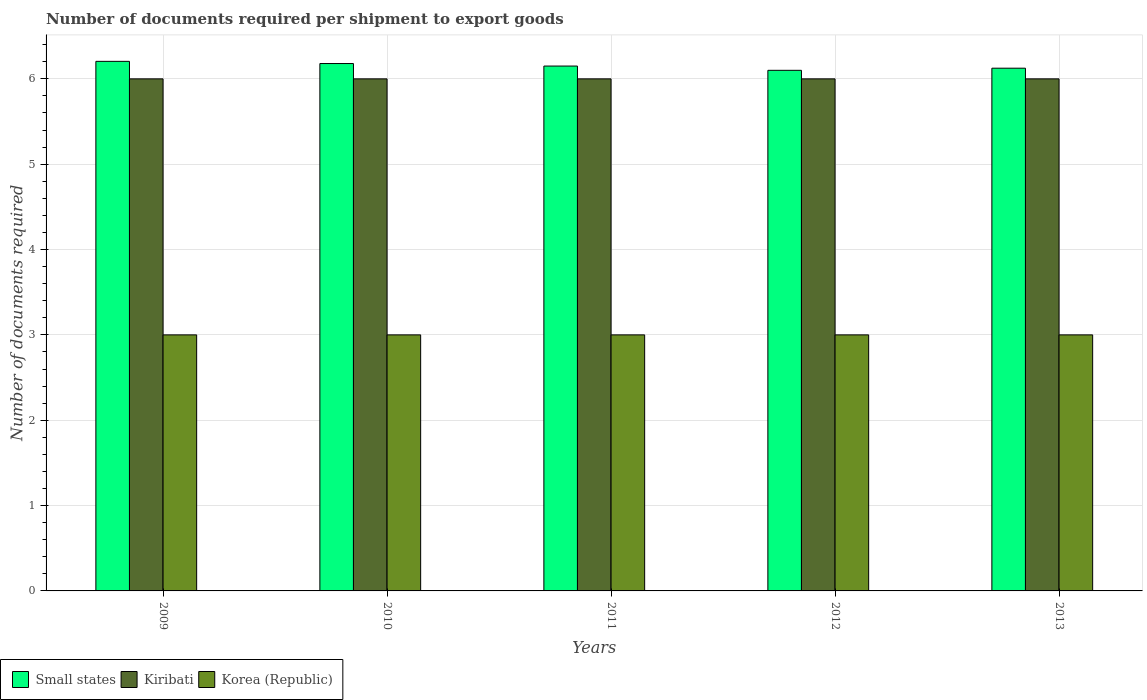How many groups of bars are there?
Your response must be concise. 5. Are the number of bars per tick equal to the number of legend labels?
Your answer should be compact. Yes. Are the number of bars on each tick of the X-axis equal?
Give a very brief answer. Yes. How many bars are there on the 1st tick from the left?
Ensure brevity in your answer.  3. How many bars are there on the 2nd tick from the right?
Offer a very short reply. 3. What is the label of the 1st group of bars from the left?
Provide a succinct answer. 2009. What is the number of documents required per shipment to export goods in Kiribati in 2010?
Your answer should be compact. 6. Across all years, what is the maximum number of documents required per shipment to export goods in Korea (Republic)?
Provide a short and direct response. 3. In which year was the number of documents required per shipment to export goods in Kiribati maximum?
Your answer should be very brief. 2009. In which year was the number of documents required per shipment to export goods in Kiribati minimum?
Keep it short and to the point. 2009. What is the total number of documents required per shipment to export goods in Kiribati in the graph?
Keep it short and to the point. 30. What is the difference between the number of documents required per shipment to export goods in Small states in 2009 and that in 2012?
Your answer should be compact. 0.11. What is the difference between the number of documents required per shipment to export goods in Kiribati in 2009 and the number of documents required per shipment to export goods in Korea (Republic) in 2012?
Keep it short and to the point. 3. In the year 2012, what is the difference between the number of documents required per shipment to export goods in Small states and number of documents required per shipment to export goods in Kiribati?
Give a very brief answer. 0.1. In how many years, is the number of documents required per shipment to export goods in Kiribati greater than 5.2?
Your answer should be very brief. 5. What is the ratio of the number of documents required per shipment to export goods in Kiribati in 2009 to that in 2013?
Provide a succinct answer. 1. Is the number of documents required per shipment to export goods in Kiribati in 2009 less than that in 2010?
Offer a terse response. No. Is the difference between the number of documents required per shipment to export goods in Small states in 2010 and 2013 greater than the difference between the number of documents required per shipment to export goods in Kiribati in 2010 and 2013?
Give a very brief answer. Yes. In how many years, is the number of documents required per shipment to export goods in Small states greater than the average number of documents required per shipment to export goods in Small states taken over all years?
Give a very brief answer. 2. Is the sum of the number of documents required per shipment to export goods in Kiribati in 2010 and 2011 greater than the maximum number of documents required per shipment to export goods in Small states across all years?
Your response must be concise. Yes. What does the 3rd bar from the right in 2009 represents?
Provide a short and direct response. Small states. Is it the case that in every year, the sum of the number of documents required per shipment to export goods in Kiribati and number of documents required per shipment to export goods in Small states is greater than the number of documents required per shipment to export goods in Korea (Republic)?
Your answer should be compact. Yes. How many bars are there?
Keep it short and to the point. 15. How many years are there in the graph?
Make the answer very short. 5. What is the difference between two consecutive major ticks on the Y-axis?
Your answer should be compact. 1. Are the values on the major ticks of Y-axis written in scientific E-notation?
Your response must be concise. No. Does the graph contain any zero values?
Give a very brief answer. No. Does the graph contain grids?
Your response must be concise. Yes. How many legend labels are there?
Your answer should be very brief. 3. How are the legend labels stacked?
Your answer should be compact. Horizontal. What is the title of the graph?
Keep it short and to the point. Number of documents required per shipment to export goods. Does "Cote d'Ivoire" appear as one of the legend labels in the graph?
Make the answer very short. No. What is the label or title of the Y-axis?
Provide a succinct answer. Number of documents required. What is the Number of documents required of Small states in 2009?
Give a very brief answer. 6.21. What is the Number of documents required of Kiribati in 2009?
Provide a short and direct response. 6. What is the Number of documents required in Small states in 2010?
Your answer should be compact. 6.18. What is the Number of documents required in Kiribati in 2010?
Your response must be concise. 6. What is the Number of documents required of Small states in 2011?
Your response must be concise. 6.15. What is the Number of documents required in Small states in 2012?
Make the answer very short. 6.1. What is the Number of documents required of Kiribati in 2012?
Keep it short and to the point. 6. What is the Number of documents required of Small states in 2013?
Keep it short and to the point. 6.12. What is the Number of documents required of Korea (Republic) in 2013?
Give a very brief answer. 3. Across all years, what is the maximum Number of documents required of Small states?
Your response must be concise. 6.21. Across all years, what is the maximum Number of documents required in Kiribati?
Offer a very short reply. 6. Across all years, what is the minimum Number of documents required in Small states?
Your answer should be compact. 6.1. What is the total Number of documents required of Small states in the graph?
Your response must be concise. 30.76. What is the total Number of documents required of Kiribati in the graph?
Provide a succinct answer. 30. What is the difference between the Number of documents required in Small states in 2009 and that in 2010?
Make the answer very short. 0.03. What is the difference between the Number of documents required in Small states in 2009 and that in 2011?
Your response must be concise. 0.06. What is the difference between the Number of documents required in Kiribati in 2009 and that in 2011?
Ensure brevity in your answer.  0. What is the difference between the Number of documents required of Small states in 2009 and that in 2012?
Ensure brevity in your answer.  0.11. What is the difference between the Number of documents required in Kiribati in 2009 and that in 2012?
Provide a short and direct response. 0. What is the difference between the Number of documents required in Small states in 2009 and that in 2013?
Your answer should be very brief. 0.08. What is the difference between the Number of documents required of Kiribati in 2009 and that in 2013?
Your answer should be compact. 0. What is the difference between the Number of documents required in Korea (Republic) in 2009 and that in 2013?
Keep it short and to the point. 0. What is the difference between the Number of documents required in Small states in 2010 and that in 2011?
Your answer should be very brief. 0.03. What is the difference between the Number of documents required of Kiribati in 2010 and that in 2011?
Provide a succinct answer. 0. What is the difference between the Number of documents required of Small states in 2010 and that in 2012?
Ensure brevity in your answer.  0.08. What is the difference between the Number of documents required of Korea (Republic) in 2010 and that in 2012?
Ensure brevity in your answer.  0. What is the difference between the Number of documents required of Small states in 2010 and that in 2013?
Keep it short and to the point. 0.05. What is the difference between the Number of documents required in Kiribati in 2011 and that in 2012?
Offer a terse response. 0. What is the difference between the Number of documents required of Small states in 2011 and that in 2013?
Offer a terse response. 0.03. What is the difference between the Number of documents required of Korea (Republic) in 2011 and that in 2013?
Your answer should be very brief. 0. What is the difference between the Number of documents required of Small states in 2012 and that in 2013?
Ensure brevity in your answer.  -0.03. What is the difference between the Number of documents required of Kiribati in 2012 and that in 2013?
Provide a short and direct response. 0. What is the difference between the Number of documents required in Small states in 2009 and the Number of documents required in Kiribati in 2010?
Your answer should be very brief. 0.21. What is the difference between the Number of documents required in Small states in 2009 and the Number of documents required in Korea (Republic) in 2010?
Provide a succinct answer. 3.21. What is the difference between the Number of documents required in Small states in 2009 and the Number of documents required in Kiribati in 2011?
Keep it short and to the point. 0.21. What is the difference between the Number of documents required in Small states in 2009 and the Number of documents required in Korea (Republic) in 2011?
Your answer should be very brief. 3.21. What is the difference between the Number of documents required of Kiribati in 2009 and the Number of documents required of Korea (Republic) in 2011?
Offer a terse response. 3. What is the difference between the Number of documents required in Small states in 2009 and the Number of documents required in Kiribati in 2012?
Offer a very short reply. 0.21. What is the difference between the Number of documents required of Small states in 2009 and the Number of documents required of Korea (Republic) in 2012?
Offer a terse response. 3.21. What is the difference between the Number of documents required of Kiribati in 2009 and the Number of documents required of Korea (Republic) in 2012?
Your response must be concise. 3. What is the difference between the Number of documents required in Small states in 2009 and the Number of documents required in Kiribati in 2013?
Keep it short and to the point. 0.21. What is the difference between the Number of documents required in Small states in 2009 and the Number of documents required in Korea (Republic) in 2013?
Give a very brief answer. 3.21. What is the difference between the Number of documents required of Small states in 2010 and the Number of documents required of Kiribati in 2011?
Keep it short and to the point. 0.18. What is the difference between the Number of documents required of Small states in 2010 and the Number of documents required of Korea (Republic) in 2011?
Your response must be concise. 3.18. What is the difference between the Number of documents required in Small states in 2010 and the Number of documents required in Kiribati in 2012?
Offer a terse response. 0.18. What is the difference between the Number of documents required in Small states in 2010 and the Number of documents required in Korea (Republic) in 2012?
Make the answer very short. 3.18. What is the difference between the Number of documents required in Small states in 2010 and the Number of documents required in Kiribati in 2013?
Your answer should be compact. 0.18. What is the difference between the Number of documents required of Small states in 2010 and the Number of documents required of Korea (Republic) in 2013?
Give a very brief answer. 3.18. What is the difference between the Number of documents required of Small states in 2011 and the Number of documents required of Korea (Republic) in 2012?
Provide a succinct answer. 3.15. What is the difference between the Number of documents required in Kiribati in 2011 and the Number of documents required in Korea (Republic) in 2012?
Provide a succinct answer. 3. What is the difference between the Number of documents required in Small states in 2011 and the Number of documents required in Korea (Republic) in 2013?
Your answer should be compact. 3.15. What is the difference between the Number of documents required in Kiribati in 2011 and the Number of documents required in Korea (Republic) in 2013?
Offer a very short reply. 3. What is the difference between the Number of documents required of Small states in 2012 and the Number of documents required of Kiribati in 2013?
Keep it short and to the point. 0.1. What is the difference between the Number of documents required in Small states in 2012 and the Number of documents required in Korea (Republic) in 2013?
Offer a very short reply. 3.1. What is the average Number of documents required in Small states per year?
Your answer should be compact. 6.15. What is the average Number of documents required in Kiribati per year?
Make the answer very short. 6. In the year 2009, what is the difference between the Number of documents required of Small states and Number of documents required of Kiribati?
Make the answer very short. 0.21. In the year 2009, what is the difference between the Number of documents required in Small states and Number of documents required in Korea (Republic)?
Your answer should be very brief. 3.21. In the year 2010, what is the difference between the Number of documents required of Small states and Number of documents required of Kiribati?
Your answer should be compact. 0.18. In the year 2010, what is the difference between the Number of documents required in Small states and Number of documents required in Korea (Republic)?
Your response must be concise. 3.18. In the year 2010, what is the difference between the Number of documents required of Kiribati and Number of documents required of Korea (Republic)?
Your answer should be compact. 3. In the year 2011, what is the difference between the Number of documents required in Small states and Number of documents required in Kiribati?
Your response must be concise. 0.15. In the year 2011, what is the difference between the Number of documents required in Small states and Number of documents required in Korea (Republic)?
Your response must be concise. 3.15. In the year 2012, what is the difference between the Number of documents required of Small states and Number of documents required of Kiribati?
Keep it short and to the point. 0.1. In the year 2012, what is the difference between the Number of documents required of Kiribati and Number of documents required of Korea (Republic)?
Keep it short and to the point. 3. In the year 2013, what is the difference between the Number of documents required of Small states and Number of documents required of Kiribati?
Keep it short and to the point. 0.12. In the year 2013, what is the difference between the Number of documents required of Small states and Number of documents required of Korea (Republic)?
Provide a short and direct response. 3.12. What is the ratio of the Number of documents required of Small states in 2009 to that in 2010?
Your response must be concise. 1. What is the ratio of the Number of documents required in Kiribati in 2009 to that in 2010?
Ensure brevity in your answer.  1. What is the ratio of the Number of documents required in Small states in 2009 to that in 2011?
Provide a short and direct response. 1.01. What is the ratio of the Number of documents required of Kiribati in 2009 to that in 2011?
Offer a very short reply. 1. What is the ratio of the Number of documents required of Small states in 2009 to that in 2012?
Your answer should be very brief. 1.02. What is the ratio of the Number of documents required of Small states in 2009 to that in 2013?
Ensure brevity in your answer.  1.01. What is the ratio of the Number of documents required of Kiribati in 2009 to that in 2013?
Make the answer very short. 1. What is the ratio of the Number of documents required in Kiribati in 2010 to that in 2011?
Provide a short and direct response. 1. What is the ratio of the Number of documents required of Korea (Republic) in 2010 to that in 2011?
Provide a succinct answer. 1. What is the ratio of the Number of documents required of Kiribati in 2010 to that in 2012?
Ensure brevity in your answer.  1. What is the ratio of the Number of documents required of Small states in 2010 to that in 2013?
Your answer should be compact. 1.01. What is the ratio of the Number of documents required of Korea (Republic) in 2010 to that in 2013?
Your response must be concise. 1. What is the ratio of the Number of documents required of Small states in 2011 to that in 2012?
Provide a short and direct response. 1.01. What is the ratio of the Number of documents required in Korea (Republic) in 2011 to that in 2012?
Make the answer very short. 1. What is the ratio of the Number of documents required of Small states in 2011 to that in 2013?
Provide a succinct answer. 1. What is the ratio of the Number of documents required of Kiribati in 2011 to that in 2013?
Your answer should be very brief. 1. What is the ratio of the Number of documents required in Kiribati in 2012 to that in 2013?
Give a very brief answer. 1. What is the difference between the highest and the second highest Number of documents required of Small states?
Your response must be concise. 0.03. What is the difference between the highest and the lowest Number of documents required of Small states?
Offer a very short reply. 0.11. What is the difference between the highest and the lowest Number of documents required of Kiribati?
Your answer should be very brief. 0. What is the difference between the highest and the lowest Number of documents required in Korea (Republic)?
Provide a short and direct response. 0. 